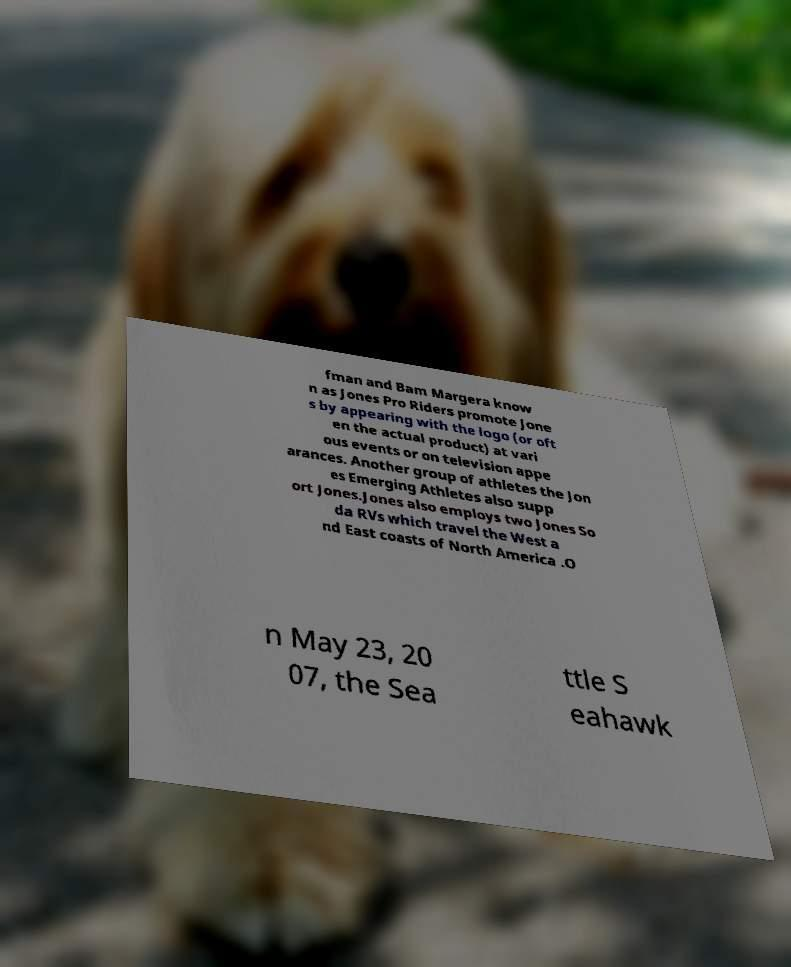There's text embedded in this image that I need extracted. Can you transcribe it verbatim? fman and Bam Margera know n as Jones Pro Riders promote Jone s by appearing with the logo (or oft en the actual product) at vari ous events or on television appe arances. Another group of athletes the Jon es Emerging Athletes also supp ort Jones.Jones also employs two Jones So da RVs which travel the West a nd East coasts of North America .O n May 23, 20 07, the Sea ttle S eahawk 